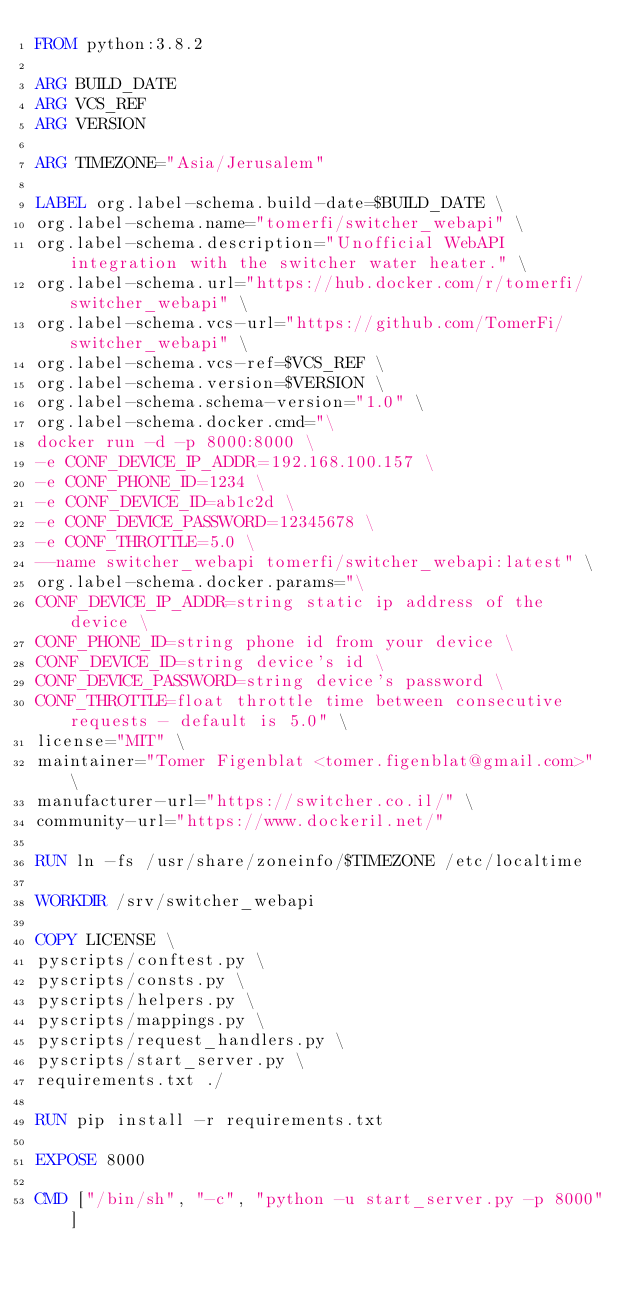Convert code to text. <code><loc_0><loc_0><loc_500><loc_500><_Dockerfile_>FROM python:3.8.2

ARG BUILD_DATE
ARG VCS_REF
ARG VERSION

ARG TIMEZONE="Asia/Jerusalem"

LABEL org.label-schema.build-date=$BUILD_DATE \
org.label-schema.name="tomerfi/switcher_webapi" \
org.label-schema.description="Unofficial WebAPI integration with the switcher water heater." \
org.label-schema.url="https://hub.docker.com/r/tomerfi/switcher_webapi" \
org.label-schema.vcs-url="https://github.com/TomerFi/switcher_webapi" \
org.label-schema.vcs-ref=$VCS_REF \
org.label-schema.version=$VERSION \
org.label-schema.schema-version="1.0" \
org.label-schema.docker.cmd="\
docker run -d -p 8000:8000 \
-e CONF_DEVICE_IP_ADDR=192.168.100.157 \
-e CONF_PHONE_ID=1234 \
-e CONF_DEVICE_ID=ab1c2d \
-e CONF_DEVICE_PASSWORD=12345678 \
-e CONF_THROTTLE=5.0 \
--name switcher_webapi tomerfi/switcher_webapi:latest" \
org.label-schema.docker.params="\
CONF_DEVICE_IP_ADDR=string static ip address of the device \
CONF_PHONE_ID=string phone id from your device \
CONF_DEVICE_ID=string device's id \
CONF_DEVICE_PASSWORD=string device's password \
CONF_THROTTLE=float throttle time between consecutive requests - default is 5.0" \
license="MIT" \
maintainer="Tomer Figenblat <tomer.figenblat@gmail.com>" \
manufacturer-url="https://switcher.co.il/" \
community-url="https://www.dockeril.net/"

RUN ln -fs /usr/share/zoneinfo/$TIMEZONE /etc/localtime

WORKDIR /srv/switcher_webapi

COPY LICENSE \
pyscripts/conftest.py \
pyscripts/consts.py \
pyscripts/helpers.py \
pyscripts/mappings.py \
pyscripts/request_handlers.py \
pyscripts/start_server.py \
requirements.txt ./

RUN pip install -r requirements.txt

EXPOSE 8000

CMD ["/bin/sh", "-c", "python -u start_server.py -p 8000"]
</code> 